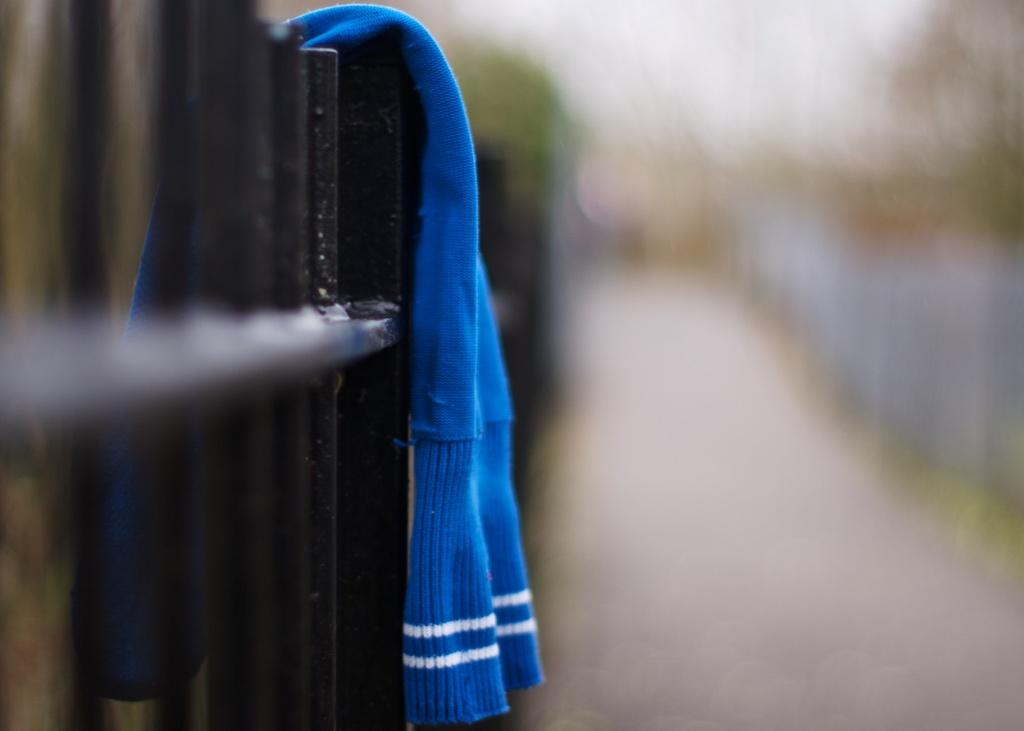What can be seen in the image related to a barrier or enclosure? There is a fencing in the image. Is there anything covering or attached to the fencing? Yes, there is a blue cloth on the fencing. What type of butter is being spread on the bread in the image? There is no bread or butter present in the image; it only features a fencing with a blue cloth. 